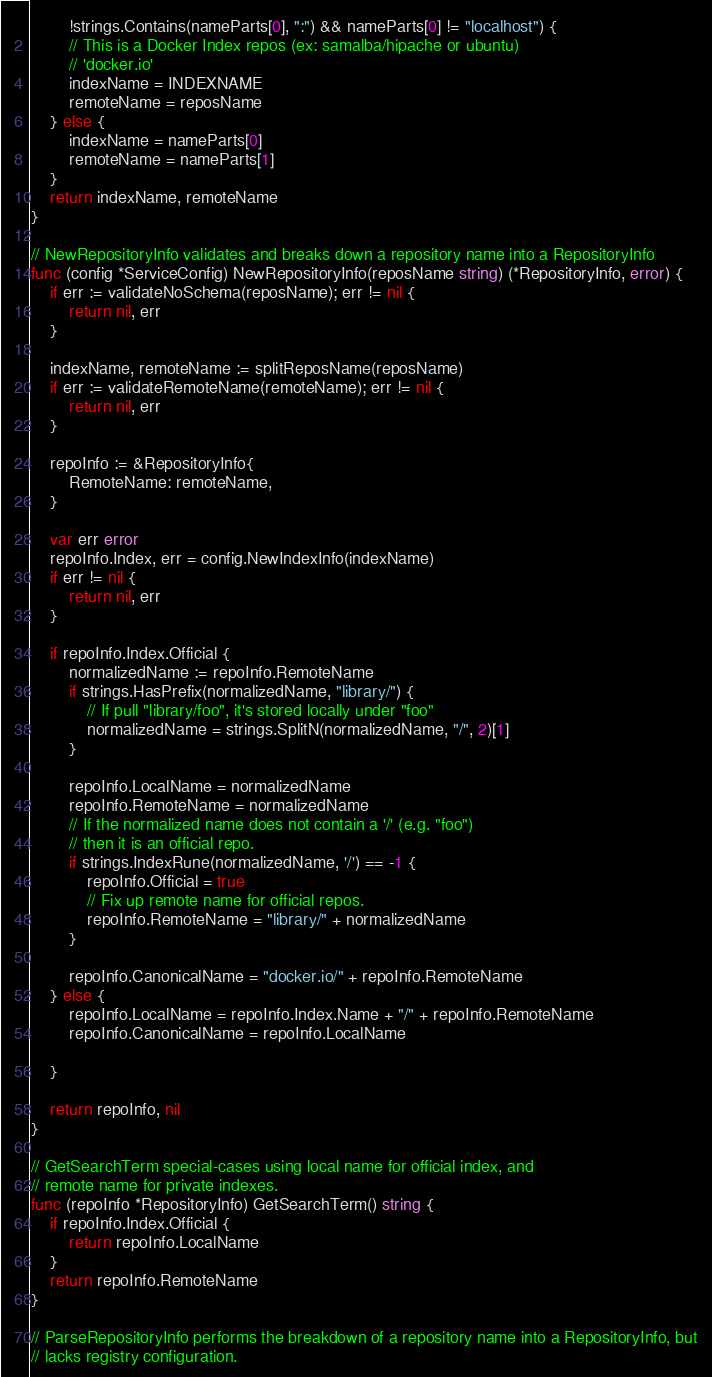Convert code to text. <code><loc_0><loc_0><loc_500><loc_500><_Go_>		!strings.Contains(nameParts[0], ":") && nameParts[0] != "localhost") {
		// This is a Docker Index repos (ex: samalba/hipache or ubuntu)
		// 'docker.io'
		indexName = INDEXNAME
		remoteName = reposName
	} else {
		indexName = nameParts[0]
		remoteName = nameParts[1]
	}
	return indexName, remoteName
}

// NewRepositoryInfo validates and breaks down a repository name into a RepositoryInfo
func (config *ServiceConfig) NewRepositoryInfo(reposName string) (*RepositoryInfo, error) {
	if err := validateNoSchema(reposName); err != nil {
		return nil, err
	}

	indexName, remoteName := splitReposName(reposName)
	if err := validateRemoteName(remoteName); err != nil {
		return nil, err
	}

	repoInfo := &RepositoryInfo{
		RemoteName: remoteName,
	}

	var err error
	repoInfo.Index, err = config.NewIndexInfo(indexName)
	if err != nil {
		return nil, err
	}

	if repoInfo.Index.Official {
		normalizedName := repoInfo.RemoteName
		if strings.HasPrefix(normalizedName, "library/") {
			// If pull "library/foo", it's stored locally under "foo"
			normalizedName = strings.SplitN(normalizedName, "/", 2)[1]
		}

		repoInfo.LocalName = normalizedName
		repoInfo.RemoteName = normalizedName
		// If the normalized name does not contain a '/' (e.g. "foo")
		// then it is an official repo.
		if strings.IndexRune(normalizedName, '/') == -1 {
			repoInfo.Official = true
			// Fix up remote name for official repos.
			repoInfo.RemoteName = "library/" + normalizedName
		}

		repoInfo.CanonicalName = "docker.io/" + repoInfo.RemoteName
	} else {
		repoInfo.LocalName = repoInfo.Index.Name + "/" + repoInfo.RemoteName
		repoInfo.CanonicalName = repoInfo.LocalName

	}

	return repoInfo, nil
}

// GetSearchTerm special-cases using local name for official index, and
// remote name for private indexes.
func (repoInfo *RepositoryInfo) GetSearchTerm() string {
	if repoInfo.Index.Official {
		return repoInfo.LocalName
	}
	return repoInfo.RemoteName
}

// ParseRepositoryInfo performs the breakdown of a repository name into a RepositoryInfo, but
// lacks registry configuration.</code> 